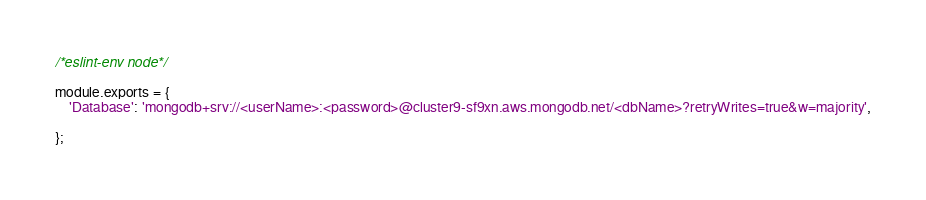Convert code to text. <code><loc_0><loc_0><loc_500><loc_500><_JavaScript_>/*eslint-env node*/

module.exports = {
    'Database': 'mongodb+srv://<userName>:<password>@cluster9-sf9xn.aws.mongodb.net/<dbName>?retryWrites=true&w=majority',

};

</code> 